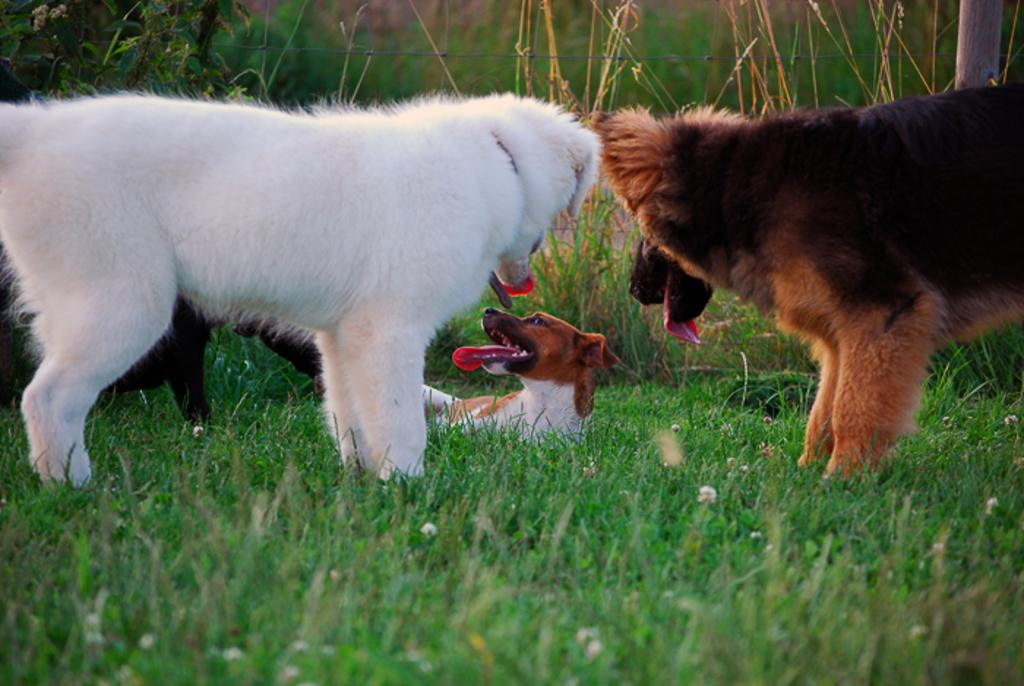What type of animals are in the image? There are dogs in the image. Can you describe the colors of the dogs? The dogs have different colors: white, brown, black, and cream. What type of terrain is visible in the image? There is grass in the image. What is the color of the grass? The grass is green. What type of drink is being served in the image? There is no drink present in the image; it features dogs on green grass. 